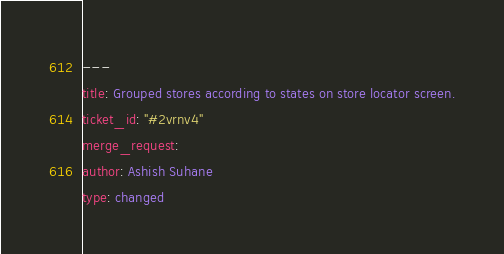<code> <loc_0><loc_0><loc_500><loc_500><_YAML_>---
title: Grouped stores according to states on store locator screen.
ticket_id: "#2vrnv4"
merge_request:
author: Ashish Suhane
type: changed
</code> 